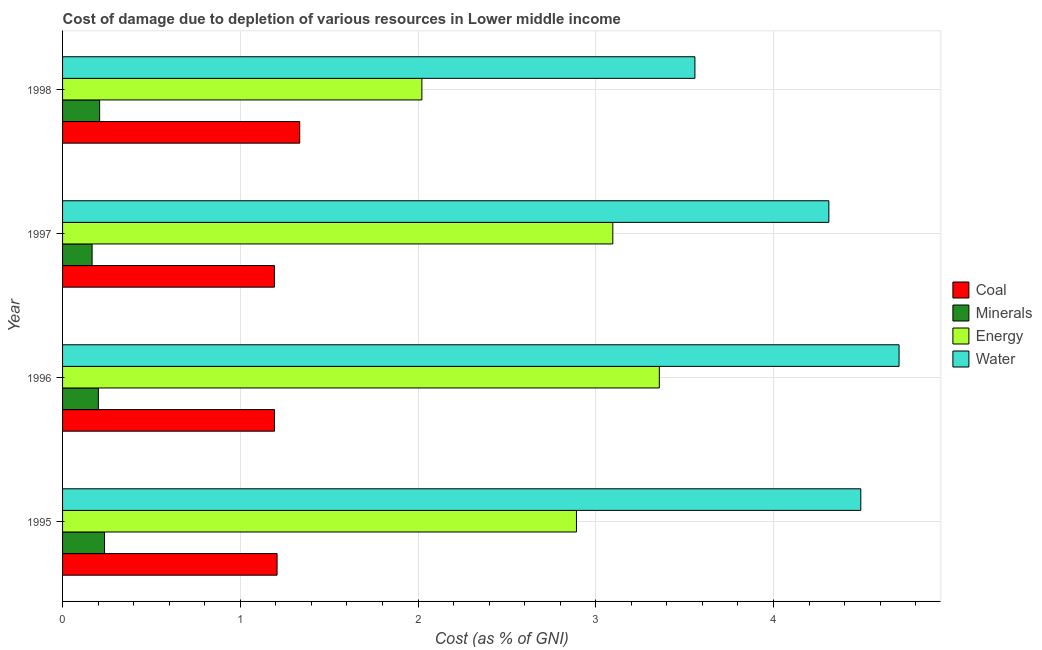How many bars are there on the 2nd tick from the bottom?
Give a very brief answer. 4. What is the label of the 1st group of bars from the top?
Your answer should be compact. 1998. In how many cases, is the number of bars for a given year not equal to the number of legend labels?
Your response must be concise. 0. What is the cost of damage due to depletion of coal in 1998?
Give a very brief answer. 1.33. Across all years, what is the maximum cost of damage due to depletion of minerals?
Keep it short and to the point. 0.24. Across all years, what is the minimum cost of damage due to depletion of coal?
Provide a succinct answer. 1.19. In which year was the cost of damage due to depletion of coal minimum?
Make the answer very short. 1997. What is the total cost of damage due to depletion of energy in the graph?
Your answer should be compact. 11.37. What is the difference between the cost of damage due to depletion of water in 1997 and that in 1998?
Provide a short and direct response. 0.75. What is the difference between the cost of damage due to depletion of water in 1997 and the cost of damage due to depletion of coal in 1998?
Offer a very short reply. 2.98. What is the average cost of damage due to depletion of minerals per year?
Your answer should be compact. 0.2. In the year 1995, what is the difference between the cost of damage due to depletion of water and cost of damage due to depletion of coal?
Offer a very short reply. 3.28. In how many years, is the cost of damage due to depletion of energy greater than 1.4 %?
Your answer should be very brief. 4. What is the ratio of the cost of damage due to depletion of energy in 1996 to that in 1998?
Ensure brevity in your answer.  1.66. Is the cost of damage due to depletion of coal in 1995 less than that in 1998?
Offer a terse response. Yes. What is the difference between the highest and the second highest cost of damage due to depletion of minerals?
Your response must be concise. 0.03. What is the difference between the highest and the lowest cost of damage due to depletion of energy?
Offer a very short reply. 1.34. Is it the case that in every year, the sum of the cost of damage due to depletion of energy and cost of damage due to depletion of water is greater than the sum of cost of damage due to depletion of coal and cost of damage due to depletion of minerals?
Your answer should be very brief. Yes. What does the 3rd bar from the top in 1997 represents?
Ensure brevity in your answer.  Minerals. What does the 4th bar from the bottom in 1995 represents?
Make the answer very short. Water. Is it the case that in every year, the sum of the cost of damage due to depletion of coal and cost of damage due to depletion of minerals is greater than the cost of damage due to depletion of energy?
Offer a terse response. No. Are all the bars in the graph horizontal?
Provide a succinct answer. Yes. How many years are there in the graph?
Your answer should be very brief. 4. Where does the legend appear in the graph?
Your answer should be compact. Center right. How are the legend labels stacked?
Your response must be concise. Vertical. What is the title of the graph?
Keep it short and to the point. Cost of damage due to depletion of various resources in Lower middle income . Does "SF6 gas" appear as one of the legend labels in the graph?
Provide a succinct answer. No. What is the label or title of the X-axis?
Make the answer very short. Cost (as % of GNI). What is the Cost (as % of GNI) of Coal in 1995?
Your answer should be very brief. 1.21. What is the Cost (as % of GNI) in Minerals in 1995?
Provide a succinct answer. 0.24. What is the Cost (as % of GNI) of Energy in 1995?
Your answer should be compact. 2.89. What is the Cost (as % of GNI) in Water in 1995?
Provide a succinct answer. 4.49. What is the Cost (as % of GNI) in Coal in 1996?
Your answer should be very brief. 1.19. What is the Cost (as % of GNI) in Minerals in 1996?
Your answer should be compact. 0.2. What is the Cost (as % of GNI) in Energy in 1996?
Your answer should be very brief. 3.36. What is the Cost (as % of GNI) of Water in 1996?
Offer a terse response. 4.71. What is the Cost (as % of GNI) in Coal in 1997?
Keep it short and to the point. 1.19. What is the Cost (as % of GNI) in Minerals in 1997?
Offer a terse response. 0.17. What is the Cost (as % of GNI) of Energy in 1997?
Your answer should be very brief. 3.1. What is the Cost (as % of GNI) in Water in 1997?
Make the answer very short. 4.31. What is the Cost (as % of GNI) in Coal in 1998?
Provide a succinct answer. 1.33. What is the Cost (as % of GNI) of Minerals in 1998?
Your response must be concise. 0.21. What is the Cost (as % of GNI) of Energy in 1998?
Offer a terse response. 2.02. What is the Cost (as % of GNI) of Water in 1998?
Give a very brief answer. 3.56. Across all years, what is the maximum Cost (as % of GNI) of Coal?
Your answer should be compact. 1.33. Across all years, what is the maximum Cost (as % of GNI) of Minerals?
Keep it short and to the point. 0.24. Across all years, what is the maximum Cost (as % of GNI) in Energy?
Provide a short and direct response. 3.36. Across all years, what is the maximum Cost (as % of GNI) of Water?
Offer a very short reply. 4.71. Across all years, what is the minimum Cost (as % of GNI) of Coal?
Ensure brevity in your answer.  1.19. Across all years, what is the minimum Cost (as % of GNI) of Minerals?
Your response must be concise. 0.17. Across all years, what is the minimum Cost (as % of GNI) of Energy?
Your answer should be very brief. 2.02. Across all years, what is the minimum Cost (as % of GNI) of Water?
Provide a short and direct response. 3.56. What is the total Cost (as % of GNI) in Coal in the graph?
Offer a terse response. 4.93. What is the total Cost (as % of GNI) in Minerals in the graph?
Offer a very short reply. 0.81. What is the total Cost (as % of GNI) of Energy in the graph?
Ensure brevity in your answer.  11.37. What is the total Cost (as % of GNI) of Water in the graph?
Give a very brief answer. 17.07. What is the difference between the Cost (as % of GNI) in Coal in 1995 and that in 1996?
Your response must be concise. 0.01. What is the difference between the Cost (as % of GNI) of Minerals in 1995 and that in 1996?
Your answer should be very brief. 0.03. What is the difference between the Cost (as % of GNI) in Energy in 1995 and that in 1996?
Provide a succinct answer. -0.47. What is the difference between the Cost (as % of GNI) in Water in 1995 and that in 1996?
Your response must be concise. -0.22. What is the difference between the Cost (as % of GNI) of Coal in 1995 and that in 1997?
Your response must be concise. 0.01. What is the difference between the Cost (as % of GNI) of Minerals in 1995 and that in 1997?
Provide a short and direct response. 0.07. What is the difference between the Cost (as % of GNI) of Energy in 1995 and that in 1997?
Give a very brief answer. -0.2. What is the difference between the Cost (as % of GNI) of Water in 1995 and that in 1997?
Provide a succinct answer. 0.18. What is the difference between the Cost (as % of GNI) of Coal in 1995 and that in 1998?
Offer a very short reply. -0.13. What is the difference between the Cost (as % of GNI) in Minerals in 1995 and that in 1998?
Provide a succinct answer. 0.03. What is the difference between the Cost (as % of GNI) of Energy in 1995 and that in 1998?
Offer a terse response. 0.87. What is the difference between the Cost (as % of GNI) in Water in 1995 and that in 1998?
Your answer should be very brief. 0.93. What is the difference between the Cost (as % of GNI) in Coal in 1996 and that in 1997?
Ensure brevity in your answer.  0. What is the difference between the Cost (as % of GNI) in Minerals in 1996 and that in 1997?
Provide a succinct answer. 0.04. What is the difference between the Cost (as % of GNI) in Energy in 1996 and that in 1997?
Your answer should be very brief. 0.26. What is the difference between the Cost (as % of GNI) of Water in 1996 and that in 1997?
Your response must be concise. 0.4. What is the difference between the Cost (as % of GNI) in Coal in 1996 and that in 1998?
Offer a terse response. -0.14. What is the difference between the Cost (as % of GNI) in Minerals in 1996 and that in 1998?
Your response must be concise. -0.01. What is the difference between the Cost (as % of GNI) in Energy in 1996 and that in 1998?
Provide a short and direct response. 1.34. What is the difference between the Cost (as % of GNI) in Water in 1996 and that in 1998?
Your answer should be compact. 1.15. What is the difference between the Cost (as % of GNI) of Coal in 1997 and that in 1998?
Offer a terse response. -0.14. What is the difference between the Cost (as % of GNI) in Minerals in 1997 and that in 1998?
Your response must be concise. -0.04. What is the difference between the Cost (as % of GNI) in Energy in 1997 and that in 1998?
Provide a short and direct response. 1.07. What is the difference between the Cost (as % of GNI) in Water in 1997 and that in 1998?
Offer a very short reply. 0.75. What is the difference between the Cost (as % of GNI) in Coal in 1995 and the Cost (as % of GNI) in Minerals in 1996?
Your response must be concise. 1.01. What is the difference between the Cost (as % of GNI) of Coal in 1995 and the Cost (as % of GNI) of Energy in 1996?
Make the answer very short. -2.15. What is the difference between the Cost (as % of GNI) in Coal in 1995 and the Cost (as % of GNI) in Water in 1996?
Keep it short and to the point. -3.5. What is the difference between the Cost (as % of GNI) in Minerals in 1995 and the Cost (as % of GNI) in Energy in 1996?
Ensure brevity in your answer.  -3.12. What is the difference between the Cost (as % of GNI) in Minerals in 1995 and the Cost (as % of GNI) in Water in 1996?
Offer a very short reply. -4.47. What is the difference between the Cost (as % of GNI) in Energy in 1995 and the Cost (as % of GNI) in Water in 1996?
Make the answer very short. -1.81. What is the difference between the Cost (as % of GNI) of Coal in 1995 and the Cost (as % of GNI) of Minerals in 1997?
Give a very brief answer. 1.04. What is the difference between the Cost (as % of GNI) in Coal in 1995 and the Cost (as % of GNI) in Energy in 1997?
Your response must be concise. -1.89. What is the difference between the Cost (as % of GNI) in Coal in 1995 and the Cost (as % of GNI) in Water in 1997?
Provide a short and direct response. -3.1. What is the difference between the Cost (as % of GNI) in Minerals in 1995 and the Cost (as % of GNI) in Energy in 1997?
Provide a succinct answer. -2.86. What is the difference between the Cost (as % of GNI) of Minerals in 1995 and the Cost (as % of GNI) of Water in 1997?
Provide a succinct answer. -4.08. What is the difference between the Cost (as % of GNI) of Energy in 1995 and the Cost (as % of GNI) of Water in 1997?
Your answer should be very brief. -1.42. What is the difference between the Cost (as % of GNI) in Coal in 1995 and the Cost (as % of GNI) in Energy in 1998?
Ensure brevity in your answer.  -0.81. What is the difference between the Cost (as % of GNI) in Coal in 1995 and the Cost (as % of GNI) in Water in 1998?
Your answer should be very brief. -2.35. What is the difference between the Cost (as % of GNI) in Minerals in 1995 and the Cost (as % of GNI) in Energy in 1998?
Ensure brevity in your answer.  -1.79. What is the difference between the Cost (as % of GNI) in Minerals in 1995 and the Cost (as % of GNI) in Water in 1998?
Ensure brevity in your answer.  -3.32. What is the difference between the Cost (as % of GNI) in Energy in 1995 and the Cost (as % of GNI) in Water in 1998?
Your answer should be very brief. -0.67. What is the difference between the Cost (as % of GNI) in Coal in 1996 and the Cost (as % of GNI) in Minerals in 1997?
Make the answer very short. 1.03. What is the difference between the Cost (as % of GNI) in Coal in 1996 and the Cost (as % of GNI) in Energy in 1997?
Your answer should be compact. -1.9. What is the difference between the Cost (as % of GNI) of Coal in 1996 and the Cost (as % of GNI) of Water in 1997?
Offer a terse response. -3.12. What is the difference between the Cost (as % of GNI) of Minerals in 1996 and the Cost (as % of GNI) of Energy in 1997?
Give a very brief answer. -2.89. What is the difference between the Cost (as % of GNI) of Minerals in 1996 and the Cost (as % of GNI) of Water in 1997?
Your answer should be compact. -4.11. What is the difference between the Cost (as % of GNI) in Energy in 1996 and the Cost (as % of GNI) in Water in 1997?
Offer a very short reply. -0.95. What is the difference between the Cost (as % of GNI) of Coal in 1996 and the Cost (as % of GNI) of Minerals in 1998?
Keep it short and to the point. 0.98. What is the difference between the Cost (as % of GNI) of Coal in 1996 and the Cost (as % of GNI) of Energy in 1998?
Your answer should be very brief. -0.83. What is the difference between the Cost (as % of GNI) in Coal in 1996 and the Cost (as % of GNI) in Water in 1998?
Your answer should be compact. -2.37. What is the difference between the Cost (as % of GNI) of Minerals in 1996 and the Cost (as % of GNI) of Energy in 1998?
Make the answer very short. -1.82. What is the difference between the Cost (as % of GNI) of Minerals in 1996 and the Cost (as % of GNI) of Water in 1998?
Give a very brief answer. -3.36. What is the difference between the Cost (as % of GNI) of Energy in 1996 and the Cost (as % of GNI) of Water in 1998?
Offer a terse response. -0.2. What is the difference between the Cost (as % of GNI) in Coal in 1997 and the Cost (as % of GNI) in Minerals in 1998?
Offer a very short reply. 0.98. What is the difference between the Cost (as % of GNI) of Coal in 1997 and the Cost (as % of GNI) of Energy in 1998?
Provide a succinct answer. -0.83. What is the difference between the Cost (as % of GNI) in Coal in 1997 and the Cost (as % of GNI) in Water in 1998?
Provide a short and direct response. -2.37. What is the difference between the Cost (as % of GNI) in Minerals in 1997 and the Cost (as % of GNI) in Energy in 1998?
Offer a terse response. -1.86. What is the difference between the Cost (as % of GNI) in Minerals in 1997 and the Cost (as % of GNI) in Water in 1998?
Give a very brief answer. -3.39. What is the difference between the Cost (as % of GNI) of Energy in 1997 and the Cost (as % of GNI) of Water in 1998?
Provide a succinct answer. -0.46. What is the average Cost (as % of GNI) of Coal per year?
Make the answer very short. 1.23. What is the average Cost (as % of GNI) in Minerals per year?
Ensure brevity in your answer.  0.2. What is the average Cost (as % of GNI) in Energy per year?
Keep it short and to the point. 2.84. What is the average Cost (as % of GNI) of Water per year?
Provide a succinct answer. 4.27. In the year 1995, what is the difference between the Cost (as % of GNI) of Coal and Cost (as % of GNI) of Minerals?
Offer a very short reply. 0.97. In the year 1995, what is the difference between the Cost (as % of GNI) of Coal and Cost (as % of GNI) of Energy?
Keep it short and to the point. -1.68. In the year 1995, what is the difference between the Cost (as % of GNI) of Coal and Cost (as % of GNI) of Water?
Your answer should be very brief. -3.28. In the year 1995, what is the difference between the Cost (as % of GNI) in Minerals and Cost (as % of GNI) in Energy?
Give a very brief answer. -2.66. In the year 1995, what is the difference between the Cost (as % of GNI) in Minerals and Cost (as % of GNI) in Water?
Give a very brief answer. -4.25. In the year 1995, what is the difference between the Cost (as % of GNI) in Energy and Cost (as % of GNI) in Water?
Make the answer very short. -1.6. In the year 1996, what is the difference between the Cost (as % of GNI) in Coal and Cost (as % of GNI) in Minerals?
Provide a short and direct response. 0.99. In the year 1996, what is the difference between the Cost (as % of GNI) of Coal and Cost (as % of GNI) of Energy?
Offer a terse response. -2.17. In the year 1996, what is the difference between the Cost (as % of GNI) of Coal and Cost (as % of GNI) of Water?
Keep it short and to the point. -3.51. In the year 1996, what is the difference between the Cost (as % of GNI) in Minerals and Cost (as % of GNI) in Energy?
Provide a succinct answer. -3.16. In the year 1996, what is the difference between the Cost (as % of GNI) in Minerals and Cost (as % of GNI) in Water?
Your answer should be very brief. -4.5. In the year 1996, what is the difference between the Cost (as % of GNI) of Energy and Cost (as % of GNI) of Water?
Your response must be concise. -1.35. In the year 1997, what is the difference between the Cost (as % of GNI) of Coal and Cost (as % of GNI) of Minerals?
Provide a short and direct response. 1.03. In the year 1997, what is the difference between the Cost (as % of GNI) in Coal and Cost (as % of GNI) in Energy?
Offer a very short reply. -1.9. In the year 1997, what is the difference between the Cost (as % of GNI) in Coal and Cost (as % of GNI) in Water?
Your answer should be very brief. -3.12. In the year 1997, what is the difference between the Cost (as % of GNI) of Minerals and Cost (as % of GNI) of Energy?
Your answer should be compact. -2.93. In the year 1997, what is the difference between the Cost (as % of GNI) of Minerals and Cost (as % of GNI) of Water?
Ensure brevity in your answer.  -4.15. In the year 1997, what is the difference between the Cost (as % of GNI) in Energy and Cost (as % of GNI) in Water?
Offer a terse response. -1.22. In the year 1998, what is the difference between the Cost (as % of GNI) in Coal and Cost (as % of GNI) in Minerals?
Your answer should be compact. 1.13. In the year 1998, what is the difference between the Cost (as % of GNI) of Coal and Cost (as % of GNI) of Energy?
Make the answer very short. -0.69. In the year 1998, what is the difference between the Cost (as % of GNI) of Coal and Cost (as % of GNI) of Water?
Offer a terse response. -2.22. In the year 1998, what is the difference between the Cost (as % of GNI) of Minerals and Cost (as % of GNI) of Energy?
Your answer should be very brief. -1.81. In the year 1998, what is the difference between the Cost (as % of GNI) of Minerals and Cost (as % of GNI) of Water?
Offer a very short reply. -3.35. In the year 1998, what is the difference between the Cost (as % of GNI) of Energy and Cost (as % of GNI) of Water?
Your answer should be compact. -1.54. What is the ratio of the Cost (as % of GNI) in Coal in 1995 to that in 1996?
Make the answer very short. 1.01. What is the ratio of the Cost (as % of GNI) in Minerals in 1995 to that in 1996?
Your answer should be very brief. 1.17. What is the ratio of the Cost (as % of GNI) in Energy in 1995 to that in 1996?
Ensure brevity in your answer.  0.86. What is the ratio of the Cost (as % of GNI) of Water in 1995 to that in 1996?
Your response must be concise. 0.95. What is the ratio of the Cost (as % of GNI) of Coal in 1995 to that in 1997?
Provide a short and direct response. 1.01. What is the ratio of the Cost (as % of GNI) of Minerals in 1995 to that in 1997?
Your response must be concise. 1.42. What is the ratio of the Cost (as % of GNI) in Energy in 1995 to that in 1997?
Offer a very short reply. 0.93. What is the ratio of the Cost (as % of GNI) in Water in 1995 to that in 1997?
Your answer should be compact. 1.04. What is the ratio of the Cost (as % of GNI) of Coal in 1995 to that in 1998?
Make the answer very short. 0.9. What is the ratio of the Cost (as % of GNI) in Minerals in 1995 to that in 1998?
Offer a very short reply. 1.13. What is the ratio of the Cost (as % of GNI) in Energy in 1995 to that in 1998?
Give a very brief answer. 1.43. What is the ratio of the Cost (as % of GNI) in Water in 1995 to that in 1998?
Provide a short and direct response. 1.26. What is the ratio of the Cost (as % of GNI) in Coal in 1996 to that in 1997?
Keep it short and to the point. 1. What is the ratio of the Cost (as % of GNI) in Minerals in 1996 to that in 1997?
Offer a very short reply. 1.21. What is the ratio of the Cost (as % of GNI) in Energy in 1996 to that in 1997?
Ensure brevity in your answer.  1.08. What is the ratio of the Cost (as % of GNI) of Water in 1996 to that in 1997?
Offer a terse response. 1.09. What is the ratio of the Cost (as % of GNI) in Coal in 1996 to that in 1998?
Offer a very short reply. 0.89. What is the ratio of the Cost (as % of GNI) in Minerals in 1996 to that in 1998?
Make the answer very short. 0.97. What is the ratio of the Cost (as % of GNI) in Energy in 1996 to that in 1998?
Give a very brief answer. 1.66. What is the ratio of the Cost (as % of GNI) in Water in 1996 to that in 1998?
Your answer should be compact. 1.32. What is the ratio of the Cost (as % of GNI) of Coal in 1997 to that in 1998?
Make the answer very short. 0.89. What is the ratio of the Cost (as % of GNI) in Minerals in 1997 to that in 1998?
Provide a succinct answer. 0.8. What is the ratio of the Cost (as % of GNI) of Energy in 1997 to that in 1998?
Your answer should be very brief. 1.53. What is the ratio of the Cost (as % of GNI) in Water in 1997 to that in 1998?
Provide a succinct answer. 1.21. What is the difference between the highest and the second highest Cost (as % of GNI) of Coal?
Offer a terse response. 0.13. What is the difference between the highest and the second highest Cost (as % of GNI) in Minerals?
Ensure brevity in your answer.  0.03. What is the difference between the highest and the second highest Cost (as % of GNI) in Energy?
Your answer should be compact. 0.26. What is the difference between the highest and the second highest Cost (as % of GNI) in Water?
Offer a terse response. 0.22. What is the difference between the highest and the lowest Cost (as % of GNI) in Coal?
Make the answer very short. 0.14. What is the difference between the highest and the lowest Cost (as % of GNI) of Minerals?
Ensure brevity in your answer.  0.07. What is the difference between the highest and the lowest Cost (as % of GNI) in Energy?
Provide a short and direct response. 1.34. What is the difference between the highest and the lowest Cost (as % of GNI) in Water?
Your answer should be compact. 1.15. 